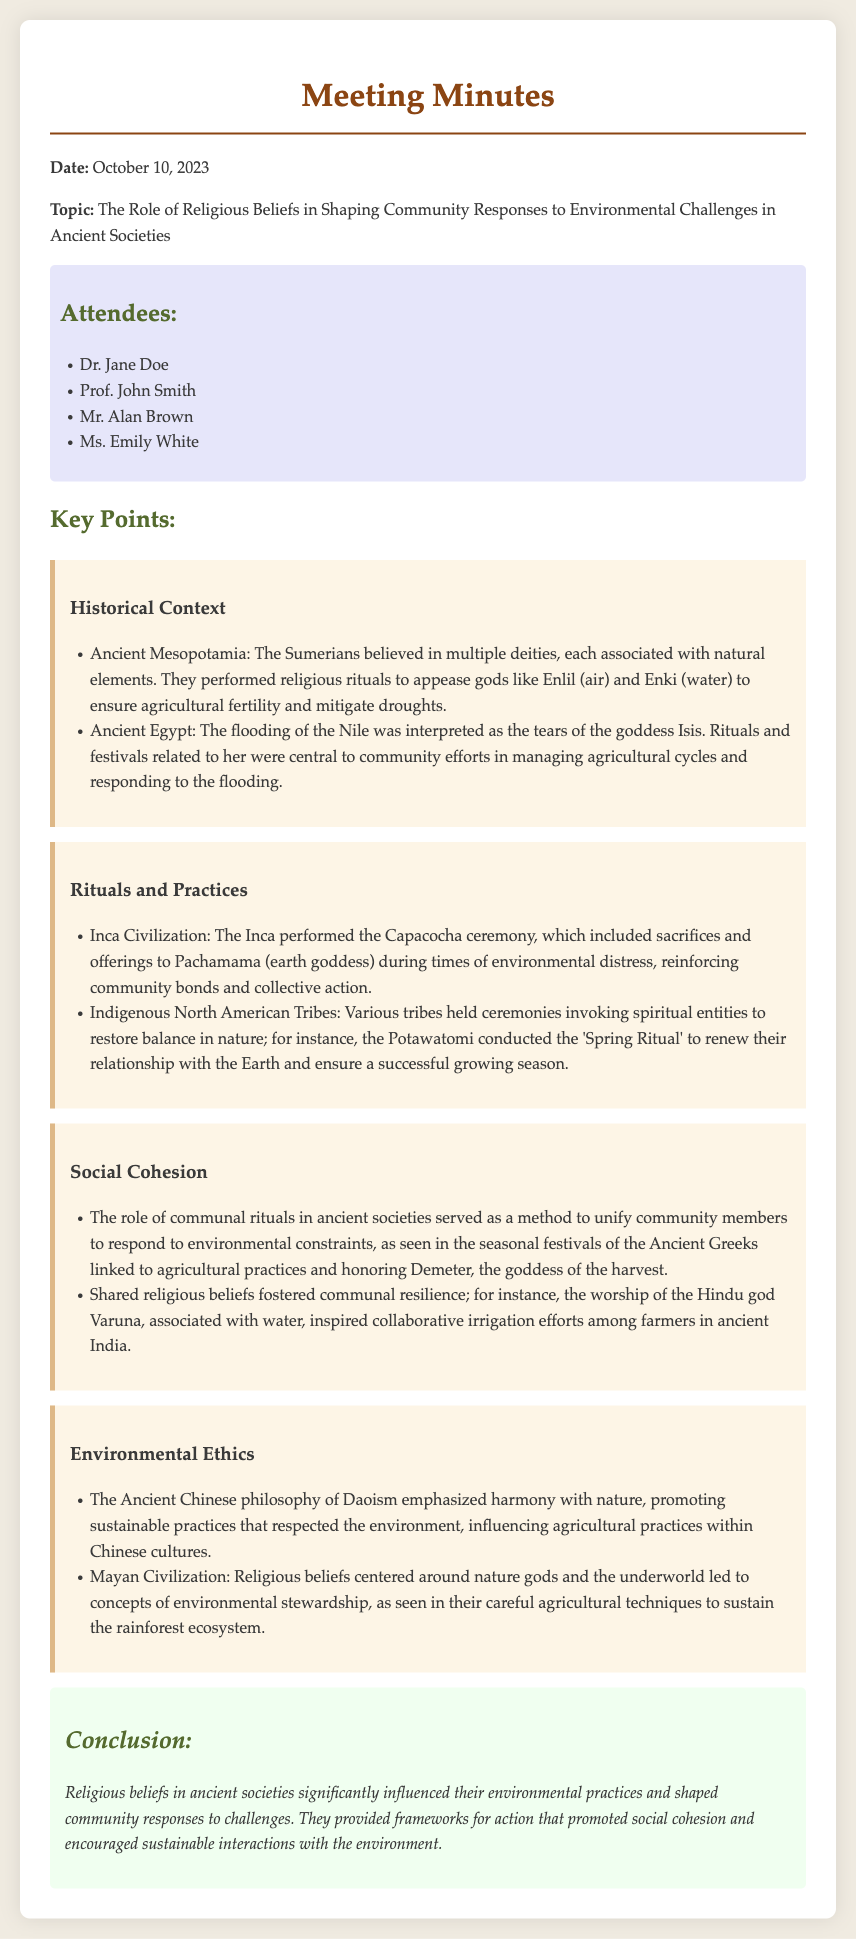What is the date of the meeting? The date of the meeting is specified in the document's header.
Answer: October 10, 2023 Who presented on the role of religious beliefs? The document contains the topic of the presentation but does not specify a presenter.
Answer: N/A Which civilization interpreted the flooding of the Nile as the tears of a goddess? This detail is noted under the section on Ancient Egypt.
Answer: Ancient Egypt What ceremony did the Inca perform during times of environmental distress? The document outlines specific rituals associated with the Inca civilization.
Answer: Capacocha ceremony What was the focus of the Ancient Chinese philosophy mentioned? The document states a specific aspect of Ancient Chinese philosophy linked to environmental practices.
Answer: Harmony with nature How did shared religious beliefs foster communal resilience in ancient India? The relevant section explains how worship inspired irrigation efforts among farmers.
Answer: Collaborative irrigation efforts Which goddess was honored during seasonal festivals by Ancient Greeks? The document identifies a certain goddess linked to Greek agricultural practices.
Answer: Demeter What is the main conclusion drawn from the discussion? The conclusion summarizes the impact of religious beliefs on environmental practices.
Answer: Significant influence 